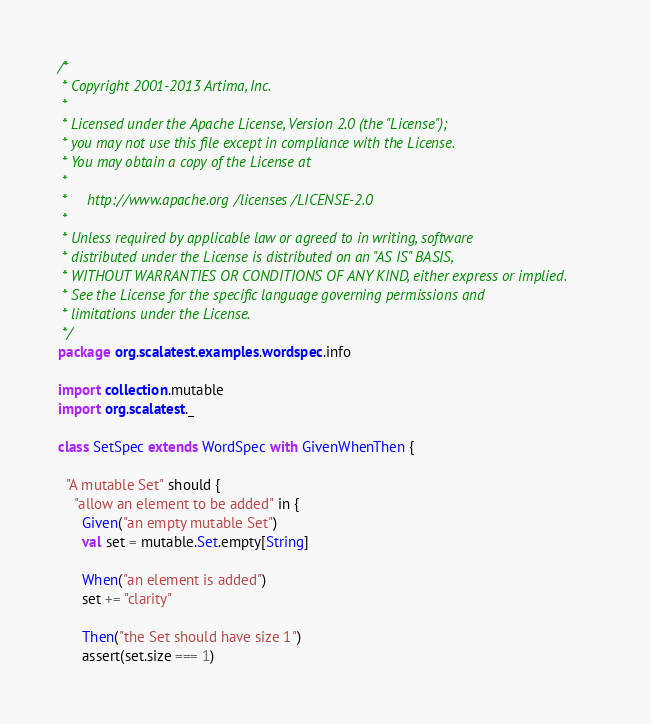Convert code to text. <code><loc_0><loc_0><loc_500><loc_500><_Scala_>/*
 * Copyright 2001-2013 Artima, Inc.
 *
 * Licensed under the Apache License, Version 2.0 (the "License");
 * you may not use this file except in compliance with the License.
 * You may obtain a copy of the License at
 *
 *     http://www.apache.org/licenses/LICENSE-2.0
 *
 * Unless required by applicable law or agreed to in writing, software
 * distributed under the License is distributed on an "AS IS" BASIS,
 * WITHOUT WARRANTIES OR CONDITIONS OF ANY KIND, either express or implied.
 * See the License for the specific language governing permissions and
 * limitations under the License.
 */
package org.scalatest.examples.wordspec.info

import collection.mutable
import org.scalatest._

class SetSpec extends WordSpec with GivenWhenThen {
  
  "A mutable Set" should {
    "allow an element to be added" in {
      Given("an empty mutable Set")
      val set = mutable.Set.empty[String]

      When("an element is added")
      set += "clarity"

      Then("the Set should have size 1")
      assert(set.size === 1)
</code> 